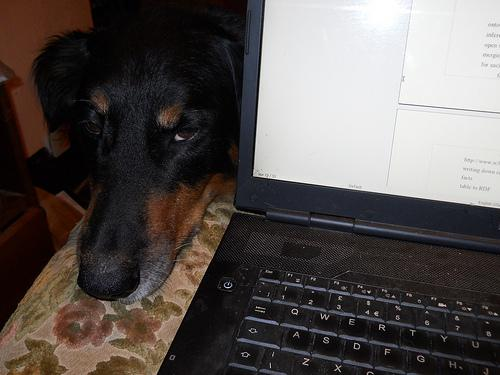Question: what type of animal is shown?
Choices:
A. Cat.
B. Frog.
C. Mice.
D. Dog.
Answer with the letter. Answer: D Question: what is beside the dog?
Choices:
A. Fan.
B. Cup.
C. Laptop.
D. Plate.
Answer with the letter. Answer: C Question: where was the photo taken?
Choices:
A. In a room.
B. Dining room.
C. Kitchen.
D. Bathroom.
Answer with the letter. Answer: A 